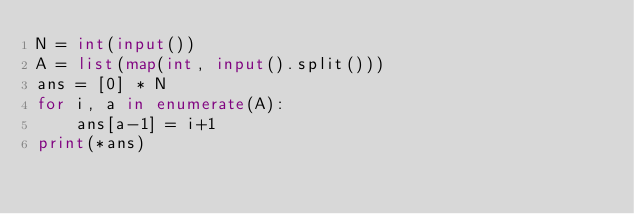Convert code to text. <code><loc_0><loc_0><loc_500><loc_500><_Python_>N = int(input())
A = list(map(int, input().split()))
ans = [0] * N
for i, a in enumerate(A):
    ans[a-1] = i+1
print(*ans)</code> 